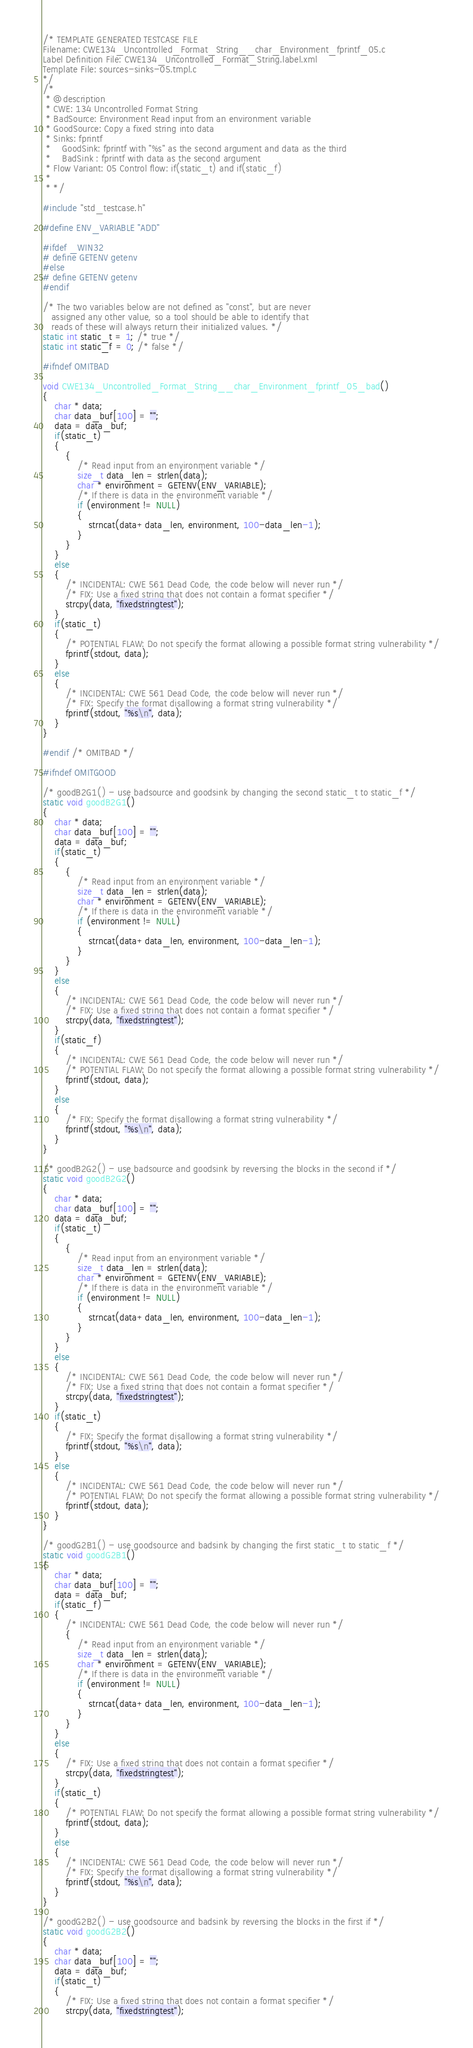<code> <loc_0><loc_0><loc_500><loc_500><_C_>/* TEMPLATE GENERATED TESTCASE FILE
Filename: CWE134_Uncontrolled_Format_String__char_Environment_fprintf_05.c
Label Definition File: CWE134_Uncontrolled_Format_String.label.xml
Template File: sources-sinks-05.tmpl.c
*/
/*
 * @description
 * CWE: 134 Uncontrolled Format String
 * BadSource: Environment Read input from an environment variable
 * GoodSource: Copy a fixed string into data
 * Sinks: fprintf
 *    GoodSink: fprintf with "%s" as the second argument and data as the third
 *    BadSink : fprintf with data as the second argument
 * Flow Variant: 05 Control flow: if(static_t) and if(static_f)
 *
 * */

#include "std_testcase.h"

#define ENV_VARIABLE "ADD"

#ifdef _WIN32
# define GETENV getenv
#else
# define GETENV getenv
#endif

/* The two variables below are not defined as "const", but are never
   assigned any other value, so a tool should be able to identify that
   reads of these will always return their initialized values. */
static int static_t = 1; /* true */
static int static_f = 0; /* false */

#ifndef OMITBAD

void CWE134_Uncontrolled_Format_String__char_Environment_fprintf_05_bad()
{
    char * data;
    char data_buf[100] = "";
    data = data_buf;
    if(static_t)
    {
        {
            /* Read input from an environment variable */
            size_t data_len = strlen(data);
            char * environment = GETENV(ENV_VARIABLE);
            /* If there is data in the environment variable */
            if (environment != NULL)
            {
                strncat(data+data_len, environment, 100-data_len-1);
            }
        }
    }
    else
    {
        /* INCIDENTAL: CWE 561 Dead Code, the code below will never run */
        /* FIX: Use a fixed string that does not contain a format specifier */
        strcpy(data, "fixedstringtest");
    }
    if(static_t)
    {
        /* POTENTIAL FLAW: Do not specify the format allowing a possible format string vulnerability */
        fprintf(stdout, data);
    }
    else
    {
        /* INCIDENTAL: CWE 561 Dead Code, the code below will never run */
        /* FIX: Specify the format disallowing a format string vulnerability */
        fprintf(stdout, "%s\n", data);
    }
}

#endif /* OMITBAD */

#ifndef OMITGOOD

/* goodB2G1() - use badsource and goodsink by changing the second static_t to static_f */
static void goodB2G1()
{
    char * data;
    char data_buf[100] = "";
    data = data_buf;
    if(static_t)
    {
        {
            /* Read input from an environment variable */
            size_t data_len = strlen(data);
            char * environment = GETENV(ENV_VARIABLE);
            /* If there is data in the environment variable */
            if (environment != NULL)
            {
                strncat(data+data_len, environment, 100-data_len-1);
            }
        }
    }
    else
    {
        /* INCIDENTAL: CWE 561 Dead Code, the code below will never run */
        /* FIX: Use a fixed string that does not contain a format specifier */
        strcpy(data, "fixedstringtest");
    }
    if(static_f)
    {
        /* INCIDENTAL: CWE 561 Dead Code, the code below will never run */
        /* POTENTIAL FLAW: Do not specify the format allowing a possible format string vulnerability */
        fprintf(stdout, data);
    }
    else
    {
        /* FIX: Specify the format disallowing a format string vulnerability */
        fprintf(stdout, "%s\n", data);
    }
}

/* goodB2G2() - use badsource and goodsink by reversing the blocks in the second if */
static void goodB2G2()
{
    char * data;
    char data_buf[100] = "";
    data = data_buf;
    if(static_t)
    {
        {
            /* Read input from an environment variable */
            size_t data_len = strlen(data);
            char * environment = GETENV(ENV_VARIABLE);
            /* If there is data in the environment variable */
            if (environment != NULL)
            {
                strncat(data+data_len, environment, 100-data_len-1);
            }
        }
    }
    else
    {
        /* INCIDENTAL: CWE 561 Dead Code, the code below will never run */
        /* FIX: Use a fixed string that does not contain a format specifier */
        strcpy(data, "fixedstringtest");
    }
    if(static_t)
    {
        /* FIX: Specify the format disallowing a format string vulnerability */
        fprintf(stdout, "%s\n", data);
    }
    else
    {
        /* INCIDENTAL: CWE 561 Dead Code, the code below will never run */
        /* POTENTIAL FLAW: Do not specify the format allowing a possible format string vulnerability */
        fprintf(stdout, data);
    }
}

/* goodG2B1() - use goodsource and badsink by changing the first static_t to static_f */
static void goodG2B1()
{
    char * data;
    char data_buf[100] = "";
    data = data_buf;
    if(static_f)
    {
        /* INCIDENTAL: CWE 561 Dead Code, the code below will never run */
        {
            /* Read input from an environment variable */
            size_t data_len = strlen(data);
            char * environment = GETENV(ENV_VARIABLE);
            /* If there is data in the environment variable */
            if (environment != NULL)
            {
                strncat(data+data_len, environment, 100-data_len-1);
            }
        }
    }
    else
    {
        /* FIX: Use a fixed string that does not contain a format specifier */
        strcpy(data, "fixedstringtest");
    }
    if(static_t)
    {
        /* POTENTIAL FLAW: Do not specify the format allowing a possible format string vulnerability */
        fprintf(stdout, data);
    }
    else
    {
        /* INCIDENTAL: CWE 561 Dead Code, the code below will never run */
        /* FIX: Specify the format disallowing a format string vulnerability */
        fprintf(stdout, "%s\n", data);
    }
}

/* goodG2B2() - use goodsource and badsink by reversing the blocks in the first if */
static void goodG2B2()
{
    char * data;
    char data_buf[100] = "";
    data = data_buf;
    if(static_t)
    {
        /* FIX: Use a fixed string that does not contain a format specifier */
        strcpy(data, "fixedstringtest");</code> 